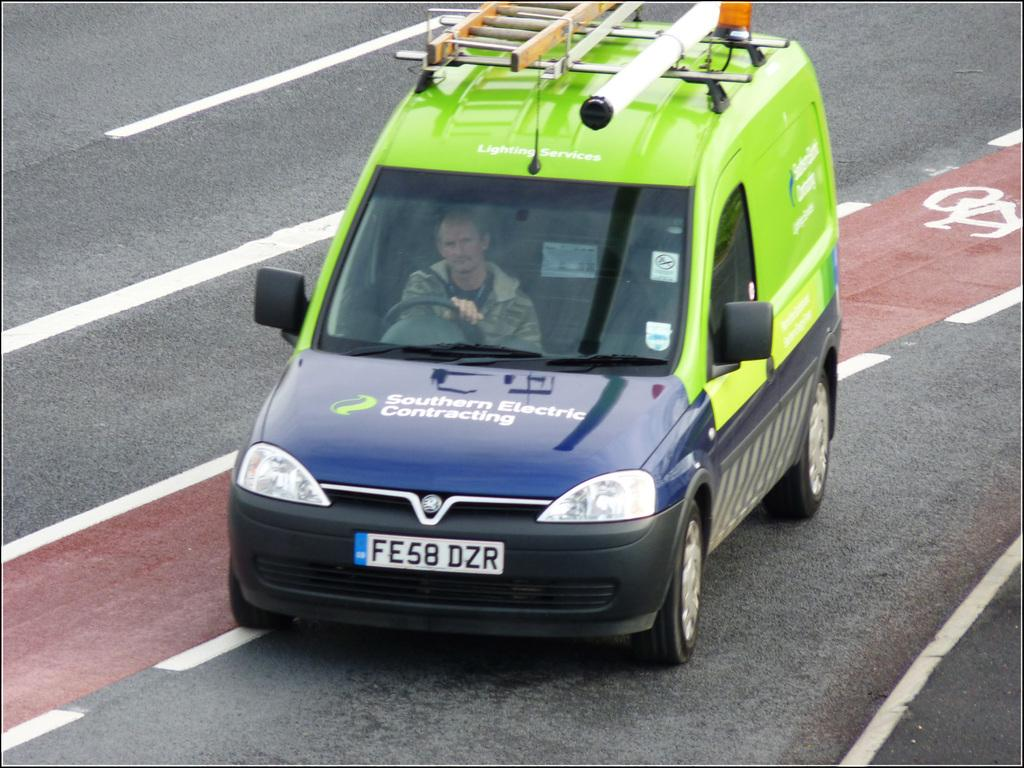What is the main subject of the picture? The main subject of the picture is a car. Where is the car located in the image? The car is on the road in the image. Who is operating the car? A person is driving the car. What is the color of the car? The car is green in color. What type of decoration is on the car? The car has bluebonnet. What can be seen in the background of the image? There is a road visible in the background of the image. How many nails are holding the lace on the car's tires in the image? There are no nails or lace present on the car's tires in the image. What type of cattle can be seen grazing near the car in the image? There are no cattle visible in the image; it only features a car on the road. 